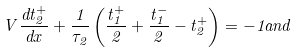Convert formula to latex. <formula><loc_0><loc_0><loc_500><loc_500>V \frac { d t _ { 2 } ^ { + } } { d x } + \frac { 1 } { \tau _ { 2 } } \left ( \frac { t _ { 1 } ^ { + } } { 2 } + \frac { t _ { 1 } ^ { - } } { 2 } - t _ { 2 } ^ { + } \right ) = - 1 a n d</formula> 